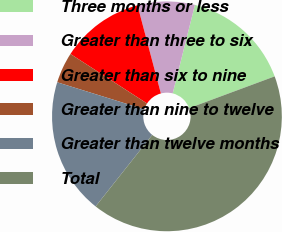<chart> <loc_0><loc_0><loc_500><loc_500><pie_chart><fcel>Three months or less<fcel>Greater than three to six<fcel>Greater than six to nine<fcel>Greater than nine to twelve<fcel>Greater than twelve months<fcel>Total<nl><fcel>15.43%<fcel>8.04%<fcel>11.74%<fcel>4.34%<fcel>19.13%<fcel>41.31%<nl></chart> 